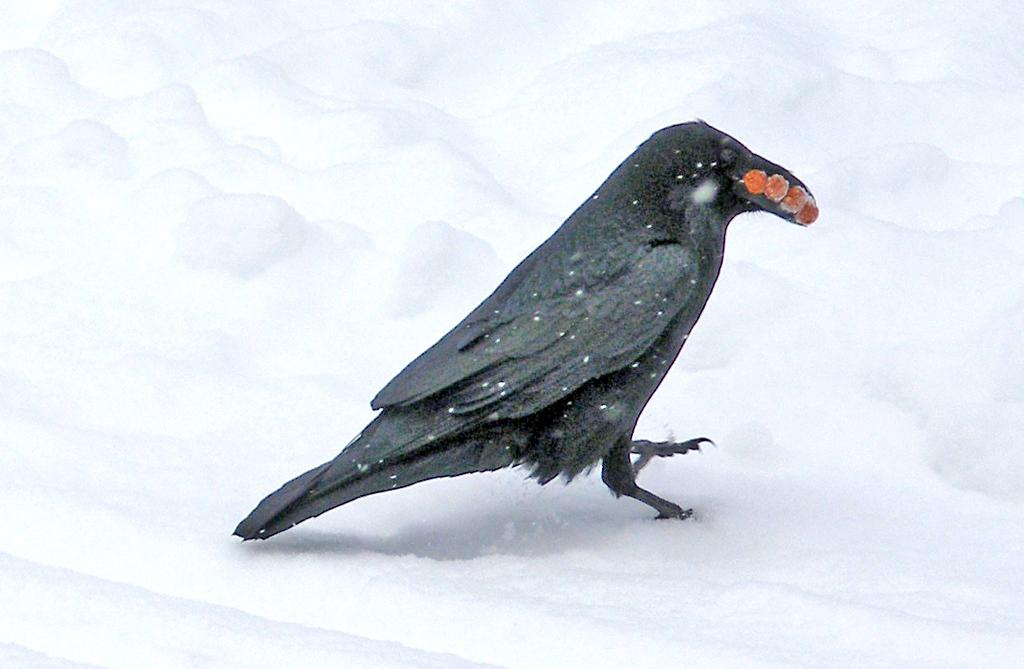What type of bird is in the picture? There is a crow in the picture. What is the crow holding in its beak? The crow has food in its beak. What color are the crow's feathers? The crow has black feathers. What is the ground covered with in the picture? There is snow on the floor in the picture. What type of kettle is visible in the picture? There is no kettle present in the picture; it features a crow with food in its beak and snow on the ground. What color is the crow's polish in the picture? Crows do not wear polish, and there is no indication of any polish in the image. 